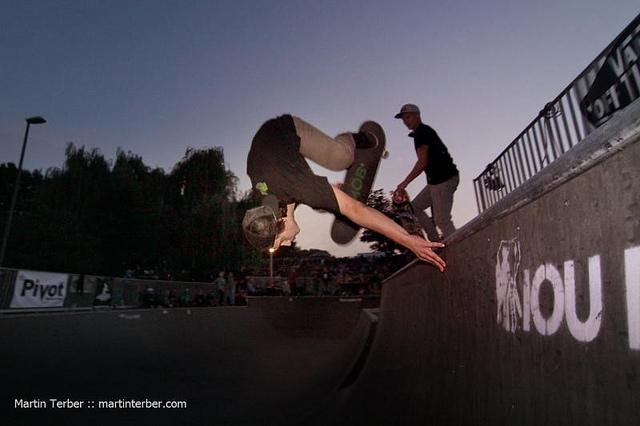Is the skater wearing a striped cap?
Keep it brief. No. Where is a banner with Pivot on it?
Keep it brief. On fence. What does the bottom say?
Answer briefly. You. How many skateboarders are in the photo?
Keep it brief. 2. What sport is this?
Write a very short answer. Skateboarding. What is the boy doing?
Answer briefly. Skateboarding. Are the boy's fingertips touching the wall?
Concise answer only. Yes. What color is the skaters shirt?
Be succinct. Black. 